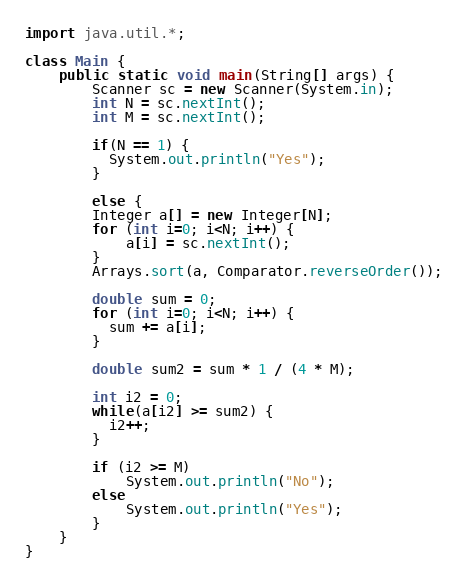<code> <loc_0><loc_0><loc_500><loc_500><_Java_>import java.util.*;

class Main {
    public static void main(String[] args) {
        Scanner sc = new Scanner(System.in);
        int N = sc.nextInt();
        int M = sc.nextInt();
      
      	if(N == 1) {
          System.out.println("Yes");
        }
        
        else {
      	Integer a[] = new Integer[N];
      	for (int i=0; i<N; i++) {
            a[i] = sc.nextInt();
        }
        Arrays.sort(a, Comparator.reverseOrder());
      
      	double sum = 0;
        for (int i=0; i<N; i++) {
          sum += a[i];
        }
      
      	double sum2 = sum * 1 / (4 * M);

      	int i2 = 0;
      	while(a[i2] >= sum2) {
          i2++;
        }
      	
      	if (i2 >= M)
            System.out.println("No");
        else
            System.out.println("Yes");
        }
    }
}</code> 